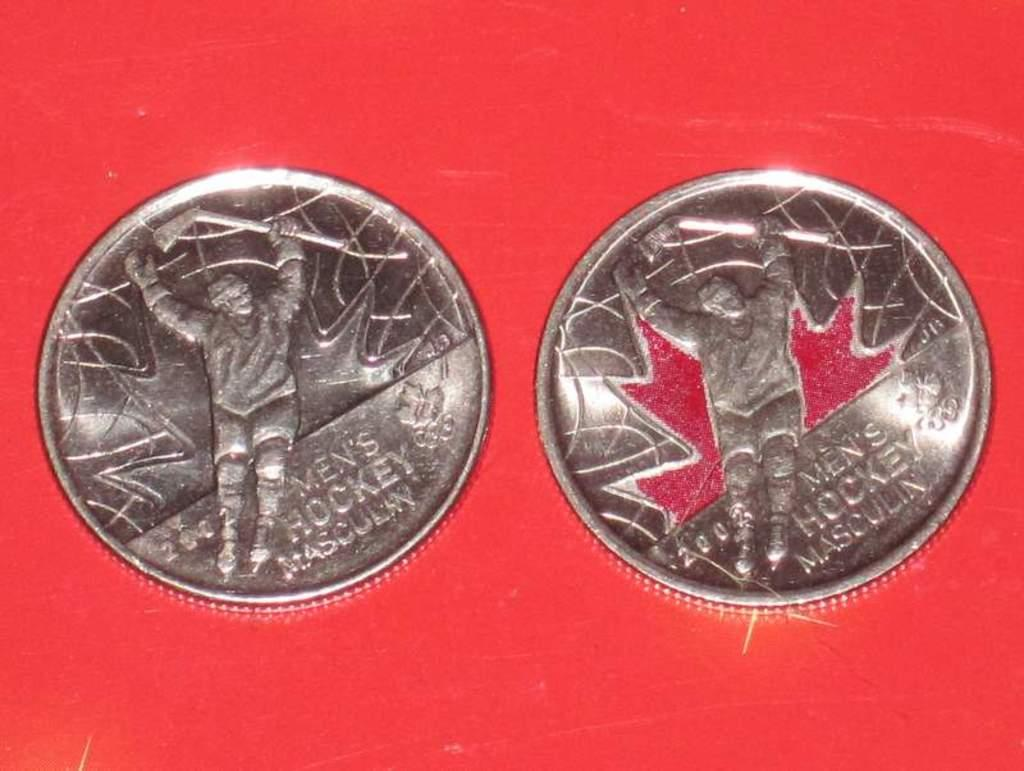<image>
Offer a succinct explanation of the picture presented. The medals shown are winning medals for men's hockey. 